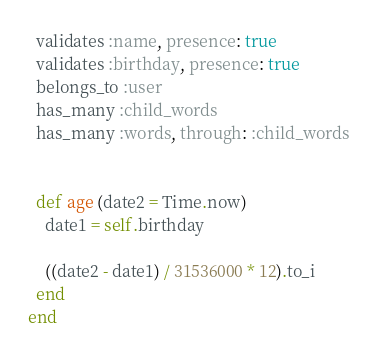Convert code to text. <code><loc_0><loc_0><loc_500><loc_500><_Ruby_>  validates :name, presence: true
  validates :birthday, presence: true
  belongs_to :user
  has_many :child_words
  has_many :words, through: :child_words

  
  def age (date2 = Time.now)
    date1 = self.birthday

    ((date2 - date1) / 31536000 * 12).to_i
  end
end
</code> 